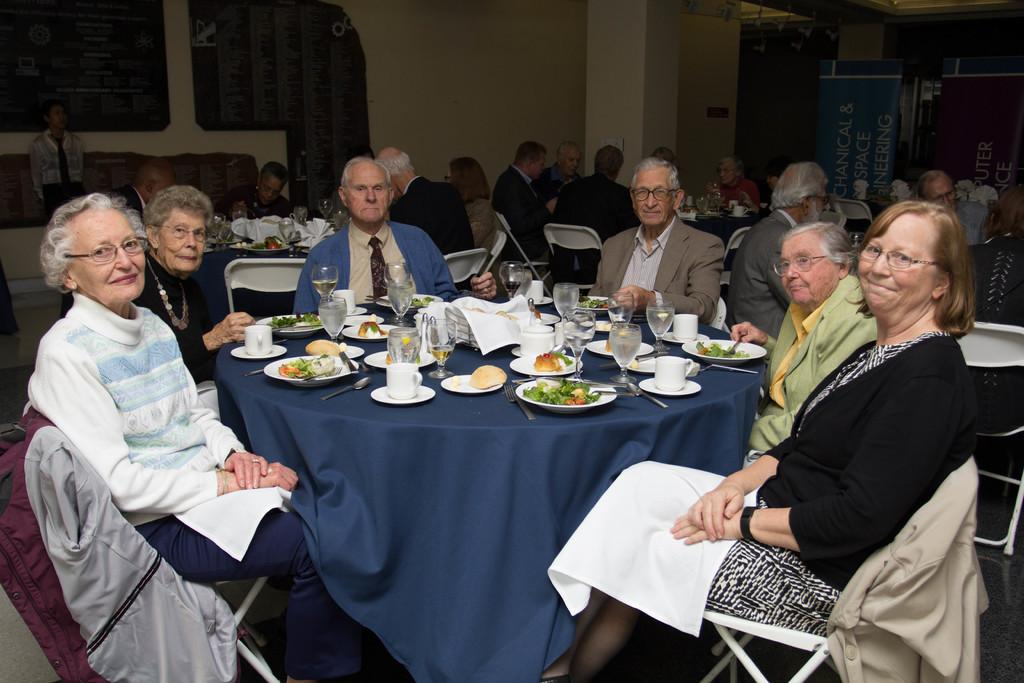How many people are in the image? There is a group of people in the image. What are the people in the image doing? The people are sitting. What objects can be seen on the table in the image? There are glasses, plates, and food on a table. Can you describe the background of the image? There are other people sitting in the background, and there is a wall visible in the background. What type of health advice is the governor giving in the image? There is no governor present in the image, and no health advice is being given. How many rings are visible on the fingers of the people in the image? There is no mention of rings in the image, and no rings are visible on the fingers of the people. 